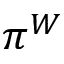Convert formula to latex. <formula><loc_0><loc_0><loc_500><loc_500>\pi ^ { W }</formula> 